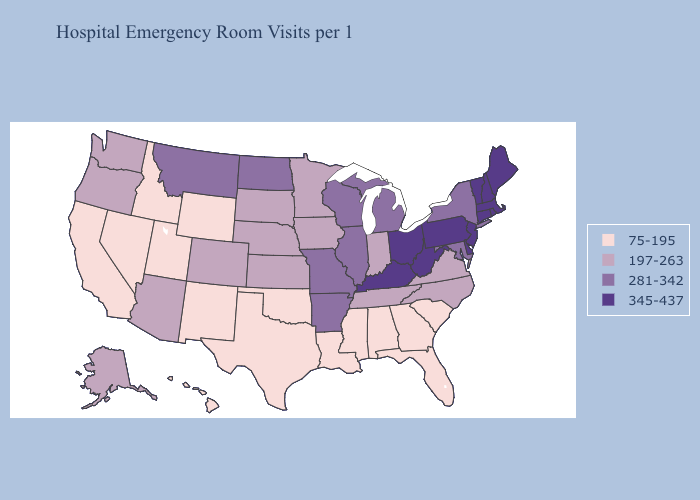Does Arkansas have the highest value in the South?
Be succinct. No. Does New York have the highest value in the Northeast?
Write a very short answer. No. Does Kentucky have the same value as Colorado?
Give a very brief answer. No. What is the value of South Dakota?
Answer briefly. 197-263. What is the value of Minnesota?
Short answer required. 197-263. Does New Hampshire have the highest value in the USA?
Give a very brief answer. Yes. What is the lowest value in states that border Nevada?
Keep it brief. 75-195. How many symbols are there in the legend?
Concise answer only. 4. How many symbols are there in the legend?
Quick response, please. 4. Which states have the lowest value in the USA?
Short answer required. Alabama, California, Florida, Georgia, Hawaii, Idaho, Louisiana, Mississippi, Nevada, New Mexico, Oklahoma, South Carolina, Texas, Utah, Wyoming. What is the lowest value in the Northeast?
Concise answer only. 281-342. What is the value of Colorado?
Concise answer only. 197-263. What is the highest value in the USA?
Answer briefly. 345-437. Which states hav the highest value in the Northeast?
Quick response, please. Connecticut, Maine, Massachusetts, New Hampshire, New Jersey, Pennsylvania, Rhode Island, Vermont. Name the states that have a value in the range 345-437?
Quick response, please. Connecticut, Delaware, Kentucky, Maine, Massachusetts, New Hampshire, New Jersey, Ohio, Pennsylvania, Rhode Island, Vermont, West Virginia. 